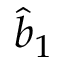Convert formula to latex. <formula><loc_0><loc_0><loc_500><loc_500>\hat { b } _ { 1 }</formula> 